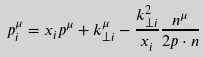<formula> <loc_0><loc_0><loc_500><loc_500>p _ { i } ^ { \mu } = x _ { i } p ^ { \mu } + k _ { \perp i } ^ { \mu } - \frac { k _ { \perp i } ^ { 2 } } { x _ { i } } \frac { n ^ { \mu } } { 2 p \cdot n } \,</formula> 